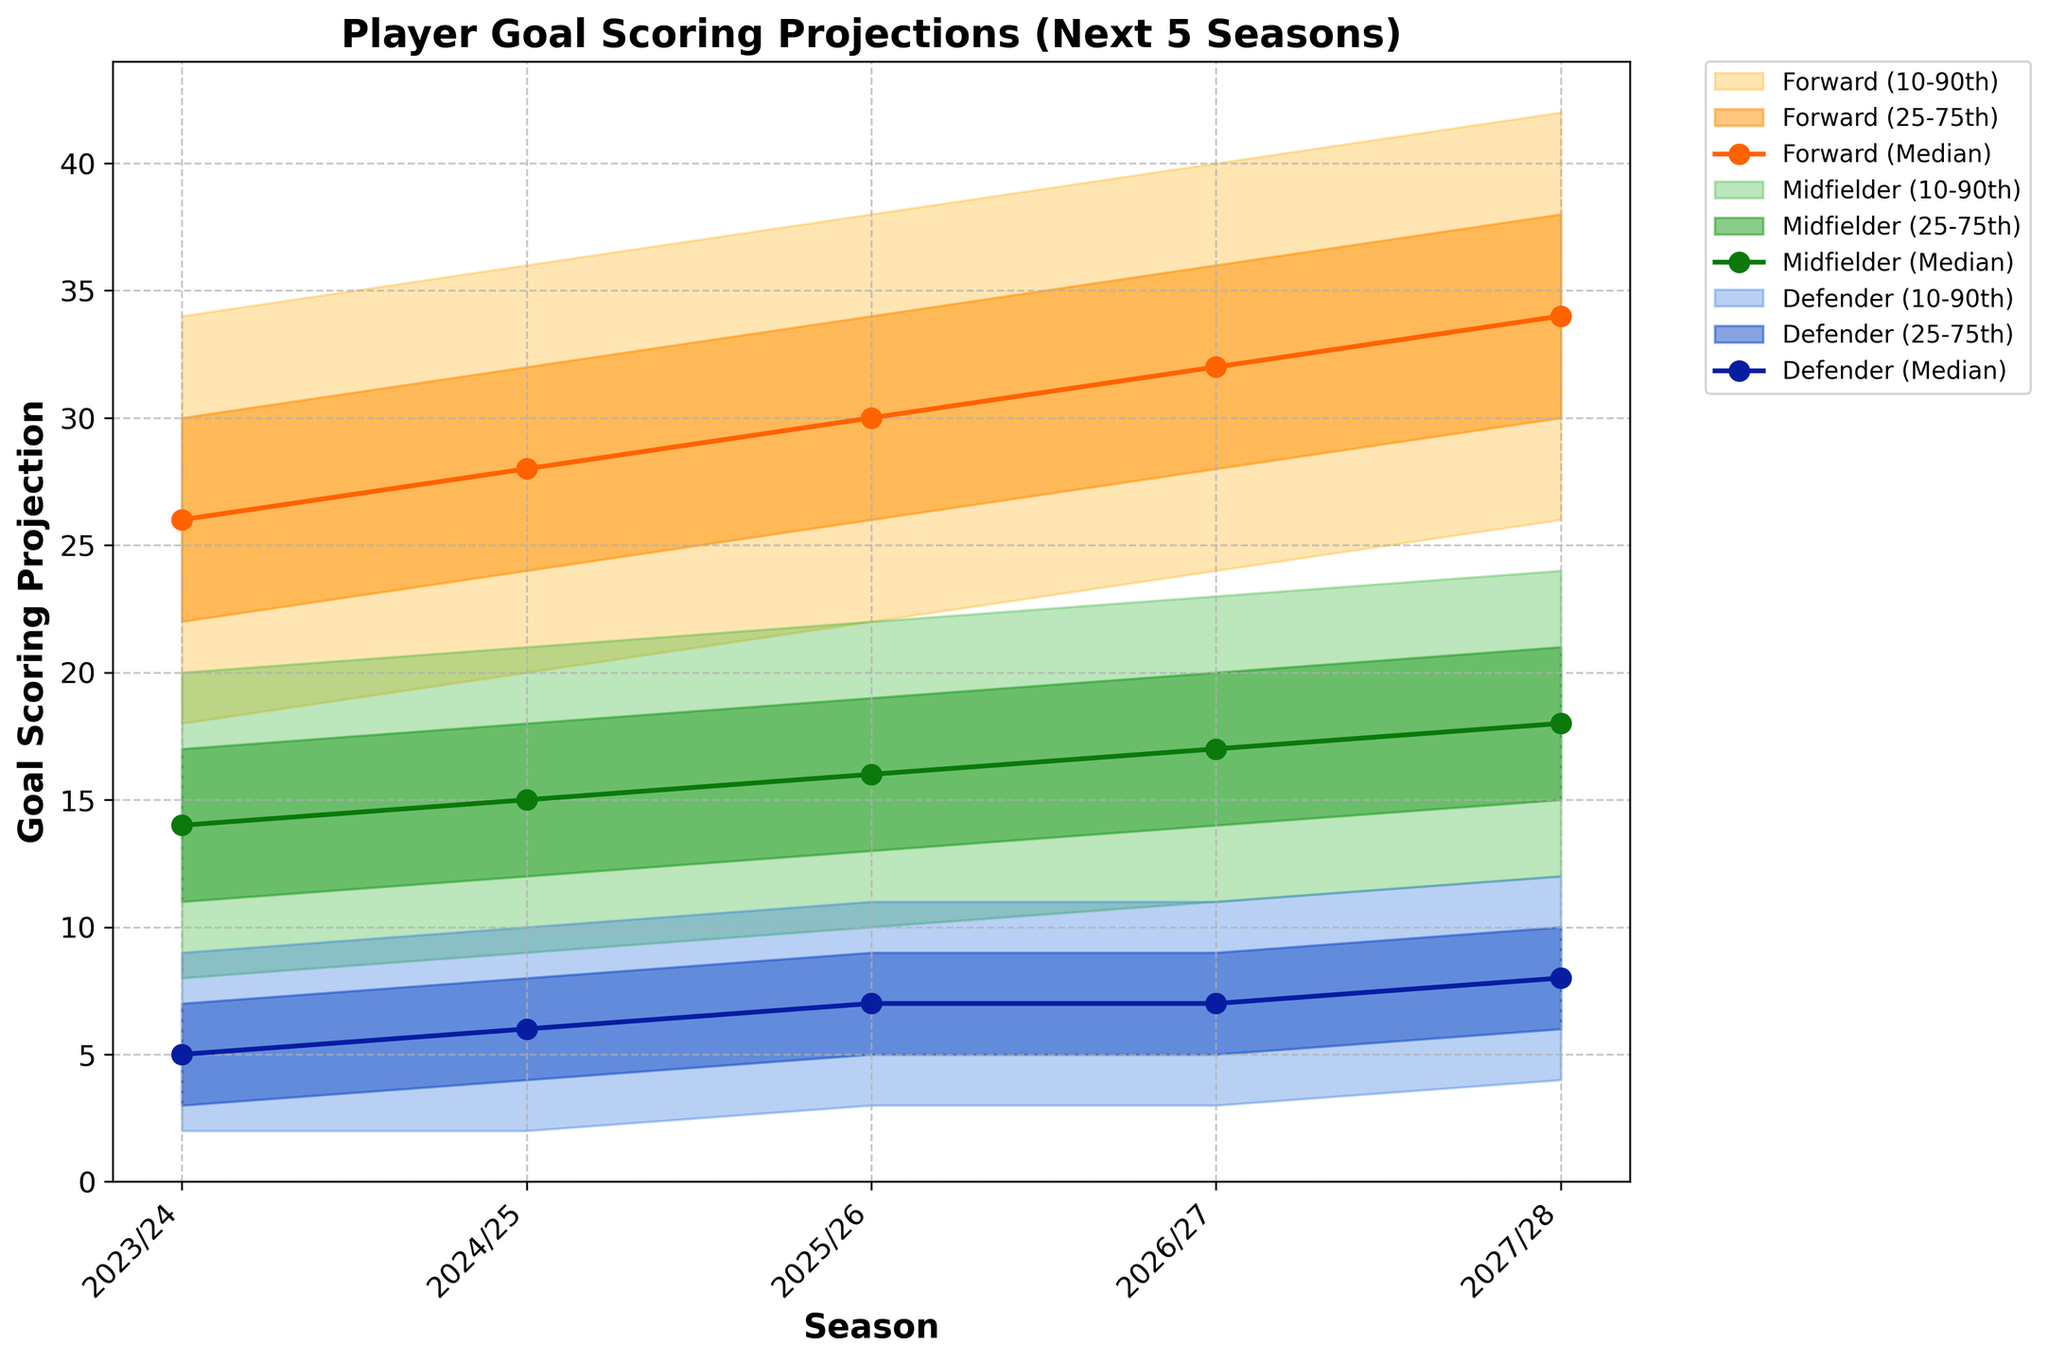Which position has the highest median goal projection for the 2023/24 season? By looking at the different positional groups for the 2023/24 season, the Forward position has the highest median goal projection at 26 goals.
Answer: Forward What's the median goal projection for midfielders in the 2025/26 season? From the plot, find the mid-value for midfielders in 2025/26, which is recorded as 16 goals.
Answer: 16 How much is the projected increase in the median goals for defenders from the 2023/24 season to the 2027/28 season? The median projection for defenders in 2023/24 is 5 goals, and in 2027/28 it is 8 goals. The increase is 8 - 5.
Answer: 3 Which season shows the smallest range between the 10th and 90th percentiles for midfielders? To find this, subtract the 10th percentile from the 90th percentile for each season for midfielders. The season with the smallest difference (20 - 8 = 12) is the 2023/24 season.
Answer: 2023/24 Between the 2024/25 and 2026/27 seasons, which season has the highest upper range (90th percentile) for forwards? Comparing the 90th percentiles for forwards in 2024/25 (36 goals) and 2026/27 (40 goals), 2026/27 has the highest upper range.
Answer: 2026/27 What is the difference between the 75th percentile projection of forwards and midfielders in the 2026/27 season? Forwards have a 75th percentile projection of 36 goals and midfielders have 20 goals. The difference is 36 - 20.
Answer: 16 Do forwards or midfielders have a more significant increase in the median goals from the 2023/24 to 2027/28 seasons? Forward medians increase from 26 to 34 goals (an increase of 8) while midfielders increase from 14 to 18 goals (an increase of 4), so forwards have a more significant increase.
Answer: Forwards Across all seasons, which position consistently shows higher goal projections? Observing all seasons, forwards consistently have higher goal projections (medians and percentiles) compared to midfielders and defenders.
Answer: Forwards 